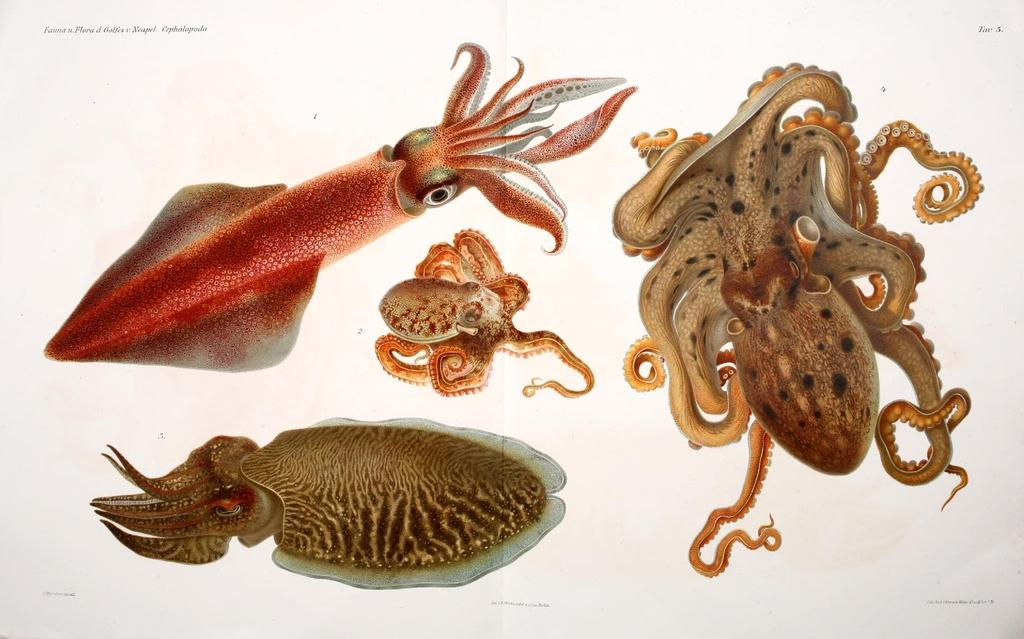What types of animals can be seen in the image? The image contains different aquatic animals. Can you describe any additional elements in the image? Yes, there is text on the top left of the image. What type of rhythm can be observed in the behavior of the aquatic animals in the image? There is no indication of rhythm or behavior in the image, as it only shows different aquatic animals and text. 